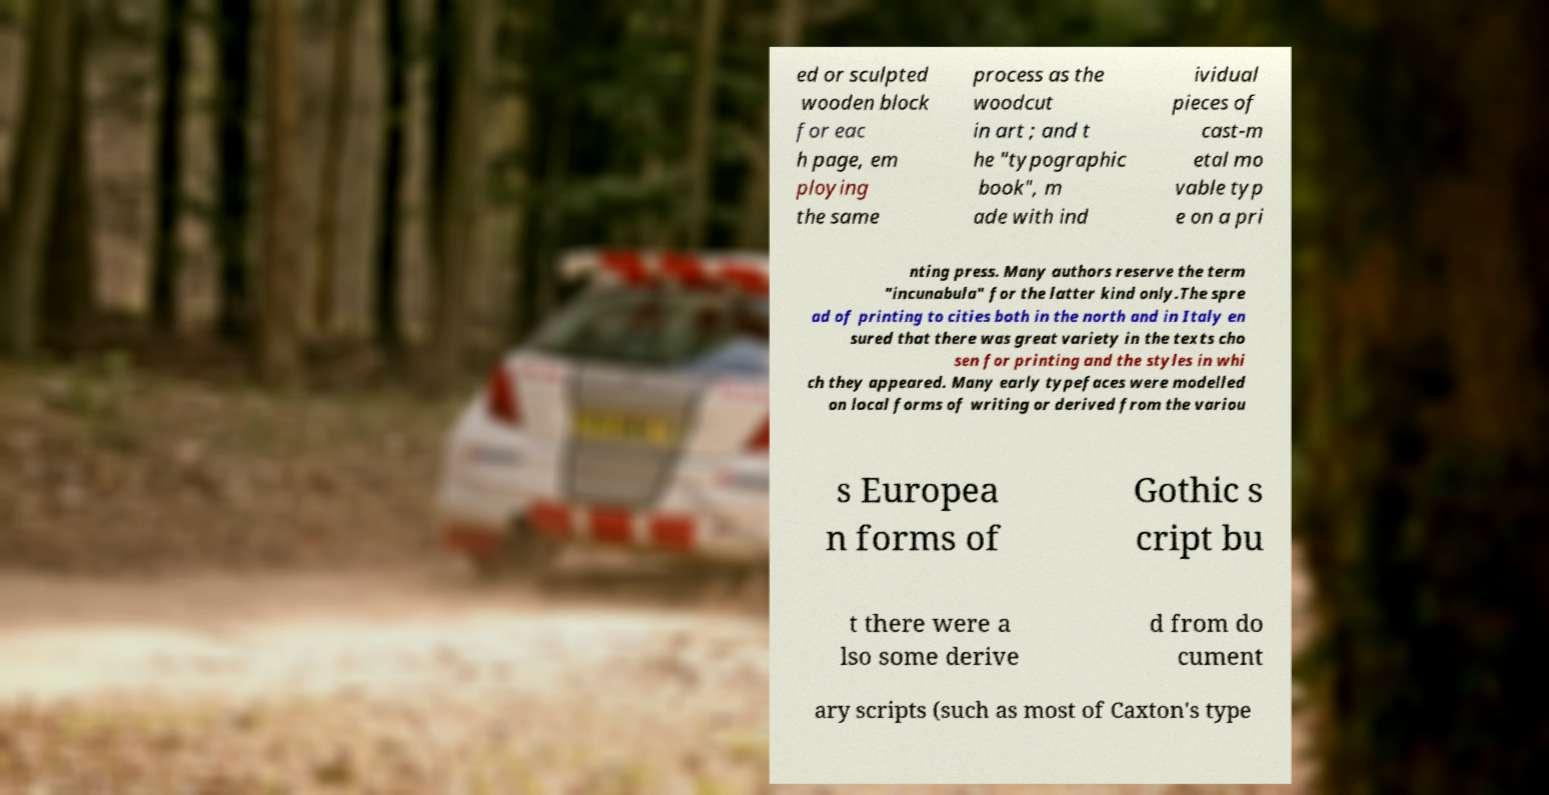Can you read and provide the text displayed in the image?This photo seems to have some interesting text. Can you extract and type it out for me? ed or sculpted wooden block for eac h page, em ploying the same process as the woodcut in art ; and t he "typographic book", m ade with ind ividual pieces of cast-m etal mo vable typ e on a pri nting press. Many authors reserve the term "incunabula" for the latter kind only.The spre ad of printing to cities both in the north and in Italy en sured that there was great variety in the texts cho sen for printing and the styles in whi ch they appeared. Many early typefaces were modelled on local forms of writing or derived from the variou s Europea n forms of Gothic s cript bu t there were a lso some derive d from do cument ary scripts (such as most of Caxton's type 